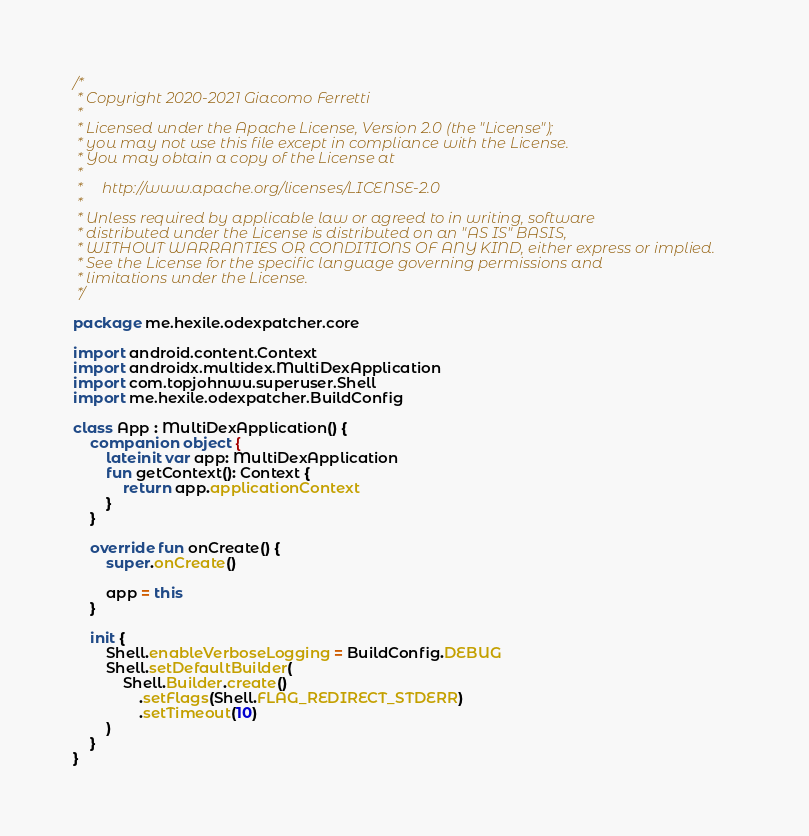Convert code to text. <code><loc_0><loc_0><loc_500><loc_500><_Kotlin_>/*
 * Copyright 2020-2021 Giacomo Ferretti
 *
 * Licensed under the Apache License, Version 2.0 (the "License");
 * you may not use this file except in compliance with the License.
 * You may obtain a copy of the License at
 *
 *     http://www.apache.org/licenses/LICENSE-2.0
 *
 * Unless required by applicable law or agreed to in writing, software
 * distributed under the License is distributed on an "AS IS" BASIS,
 * WITHOUT WARRANTIES OR CONDITIONS OF ANY KIND, either express or implied.
 * See the License for the specific language governing permissions and
 * limitations under the License.
 */

package me.hexile.odexpatcher.core

import android.content.Context
import androidx.multidex.MultiDexApplication
import com.topjohnwu.superuser.Shell
import me.hexile.odexpatcher.BuildConfig

class App : MultiDexApplication() {
    companion object {
        lateinit var app: MultiDexApplication
        fun getContext(): Context {
            return app.applicationContext
        }
    }

    override fun onCreate() {
        super.onCreate()

        app = this
    }

    init {
        Shell.enableVerboseLogging = BuildConfig.DEBUG
        Shell.setDefaultBuilder(
            Shell.Builder.create()
                .setFlags(Shell.FLAG_REDIRECT_STDERR)
                .setTimeout(10)
        )
    }
}</code> 